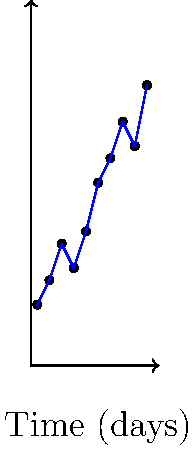Given the stock price chart above, which type of Recurrent Neural Network (RNN) architecture would be most suitable for predicting the next day's stock price, and why? To answer this question, let's consider the characteristics of the given time series data and the properties of different RNN architectures:

1. Data characteristics:
   - The data shows a stock price trend over 10 days.
   - There are both short-term fluctuations and a general upward trend.

2. RNN architectures to consider:
   a) Simple RNN
   b) Long Short-Term Memory (LSTM)
   c) Gated Recurrent Unit (GRU)

3. Analysis:
   a) Simple RNN:
      - Good for short-term dependencies
      - Suffers from vanishing gradient problem for long sequences
   
   b) LSTM:
      - Designed to capture long-term dependencies
      - Has mechanisms to remember and forget information
      - Can handle both short-term and long-term patterns
   
   c) GRU:
      - Similar to LSTM but with a simpler structure
      - Can also capture long-term dependencies
      - Generally faster to train than LSTM

4. Conclusion:
   For stock price prediction, capturing both short-term fluctuations and long-term trends is crucial. While both LSTM and GRU are capable of handling this task, LSTM is often preferred in finance due to its ability to maintain separate memory cells, which can be beneficial for capturing complex patterns in stock data.

Therefore, the most suitable RNN architecture for this task would be LSTM.
Answer: LSTM (Long Short-Term Memory) 